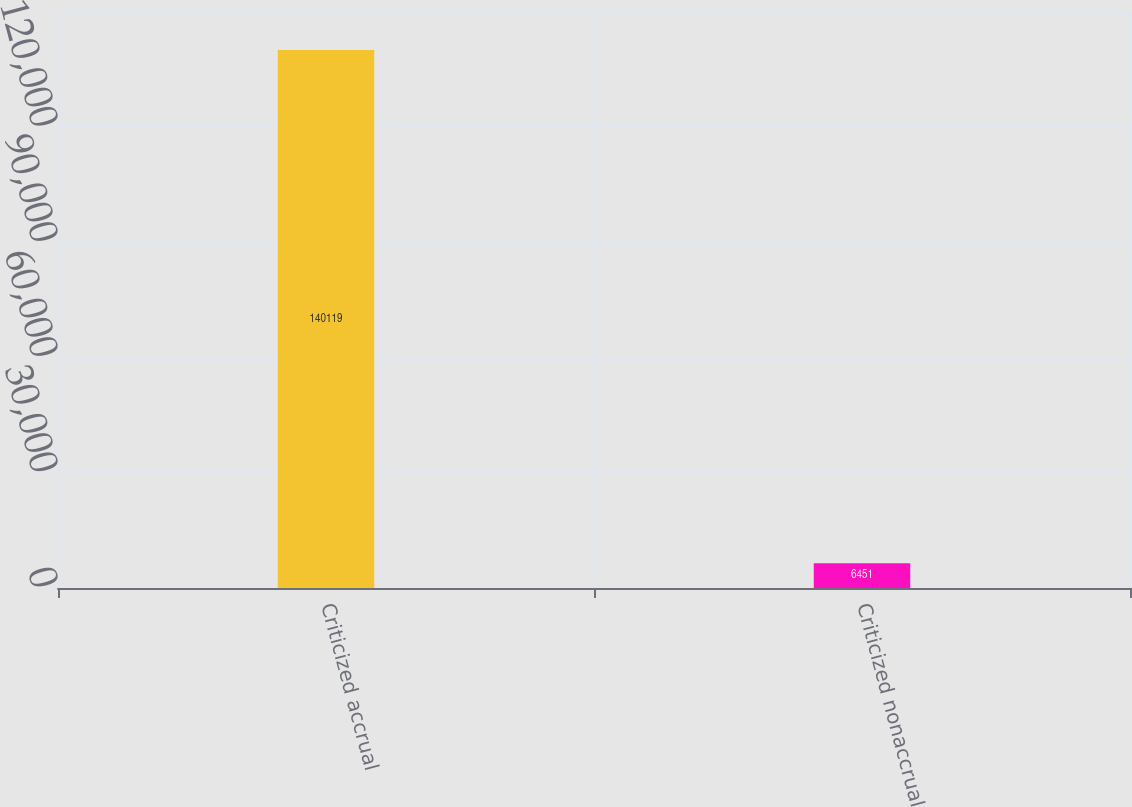Convert chart. <chart><loc_0><loc_0><loc_500><loc_500><bar_chart><fcel>Criticized accrual<fcel>Criticized nonaccrual<nl><fcel>140119<fcel>6451<nl></chart> 